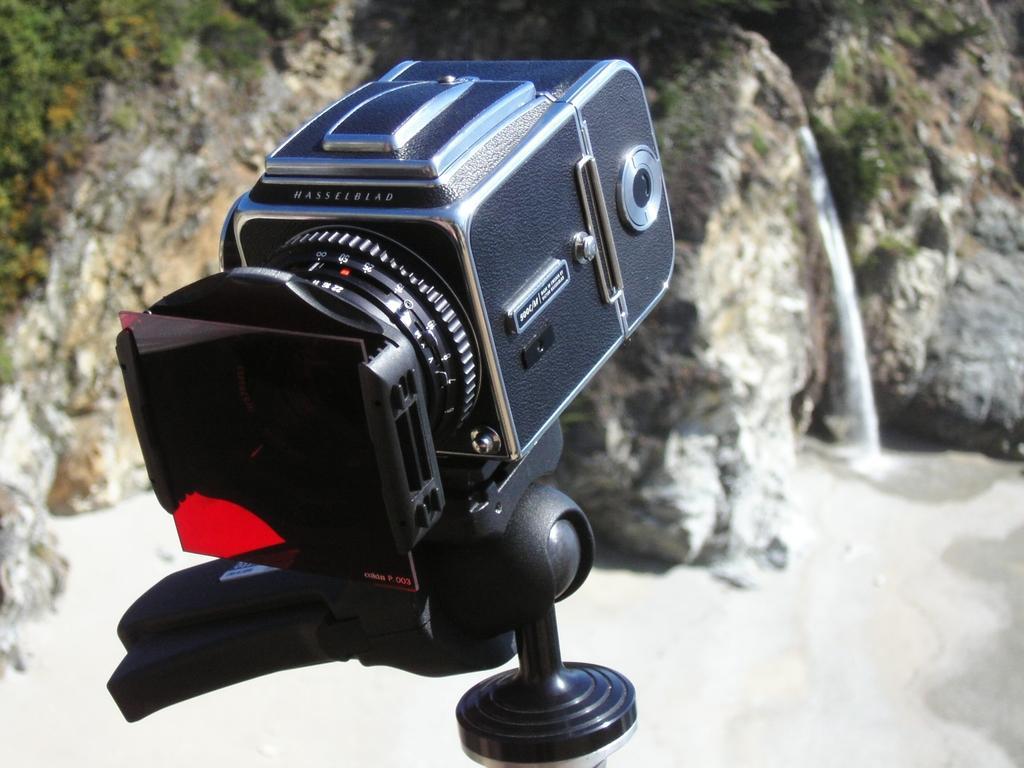Describe this image in one or two sentences. In this picture we can see a camera, in the background we can see few plants, rocks and water. 